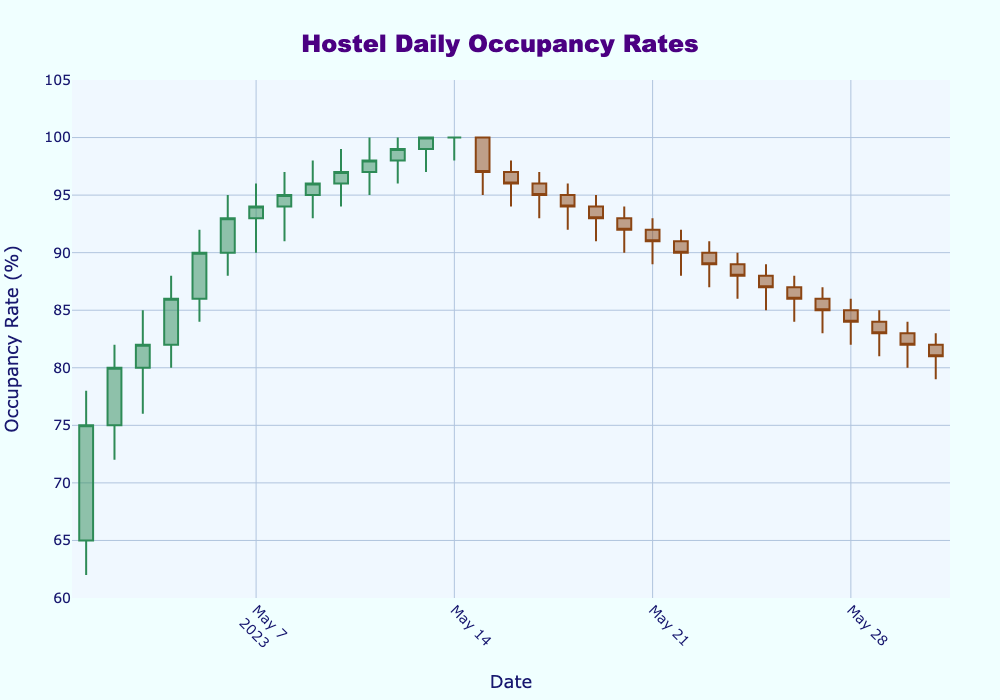What's the title of the figure? The title of the figure is usually located at the top and center of the chart. In this case, it reads "Hostel Daily Occupancy Rates".
Answer: Hostel Daily Occupancy Rates What are the colors used to indicate increasing and decreasing occupancy rates? The increasing occupancy rates are indicated in dark sea green, while the decreasing rates are shown in saddle brown.
Answer: dark sea green and saddle brown What was the highest occupancy rate reached, and on which day? Identify the highest point in the "High" column. The highest occupancy rate reached was 100%, and it first occurred on May 11th, continuing through May 14th.
Answer: 100% on May 11th Which day shows the largest increase in occupancy rate from opening to closing? Look for the largest difference between the Open and Close values. May 14th had a Close rate of 100% and an Open rate of 99%, making the increase 1%.
Answer: May 14th What pattern can be observed in the occupancy rates from May 1st to May 14th? Notice the trend by following the Close values daily: the occupancy rates show a steady increase from 75% on May 1st to 100% on May 13th and 14th.
Answer: Steady increase to 100% When did the occupancy rates start to decline? Observe the series of Close values to find the first decline after the highest occupancy. The decline starts right after May 14th, on May 15th when the occupancy rate drops to 97%.
Answer: May 15th How many days in May had a closing occupancy rate of 100%? Count the number of days where the Close value is 100%. There were 3 days: May 13th, May 14th, and May 11th.
Answer: 3 days What was the lowest occupancy rate observed in May, and when did it occur? Identify the smallest value in the "Low" column. The lowest occupancy rate was 79%, which occurred on May 31st.
Answer: 79% on May 31st Compare the occupancy rate trends in the first half of the month with the second half. The first half of the month (May 1st to May 14th) shows increasing occupancy rates, peaking at 100%. The second half (May 15th to May 31st) shows a downward trend, bringing the rate down to 81%.
Answer: Increase in the first half, decrease in the second half 